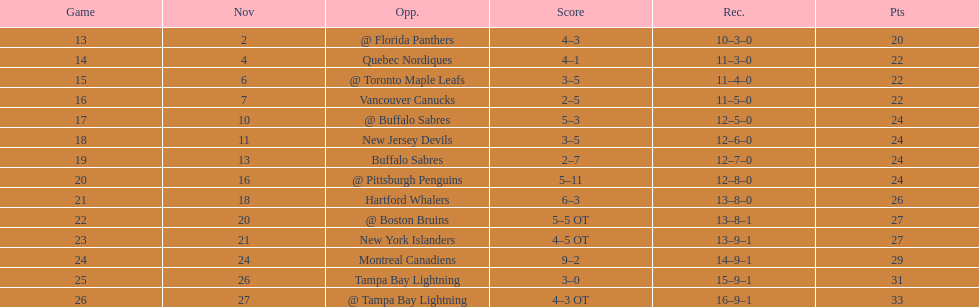What was the total penalty minutes that dave brown had on the 1993-1994 flyers? 137. 